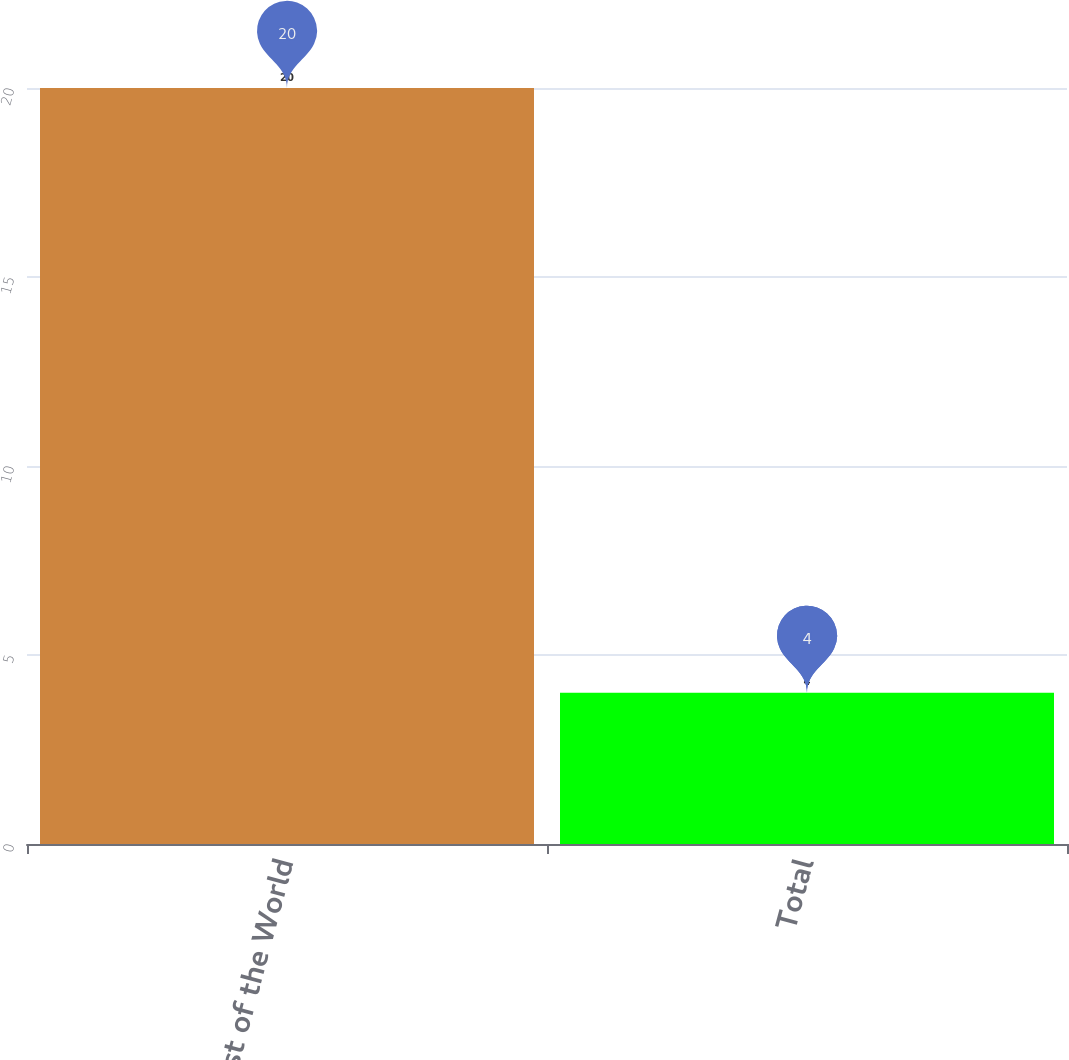<chart> <loc_0><loc_0><loc_500><loc_500><bar_chart><fcel>Rest of the World<fcel>Total<nl><fcel>20<fcel>4<nl></chart> 